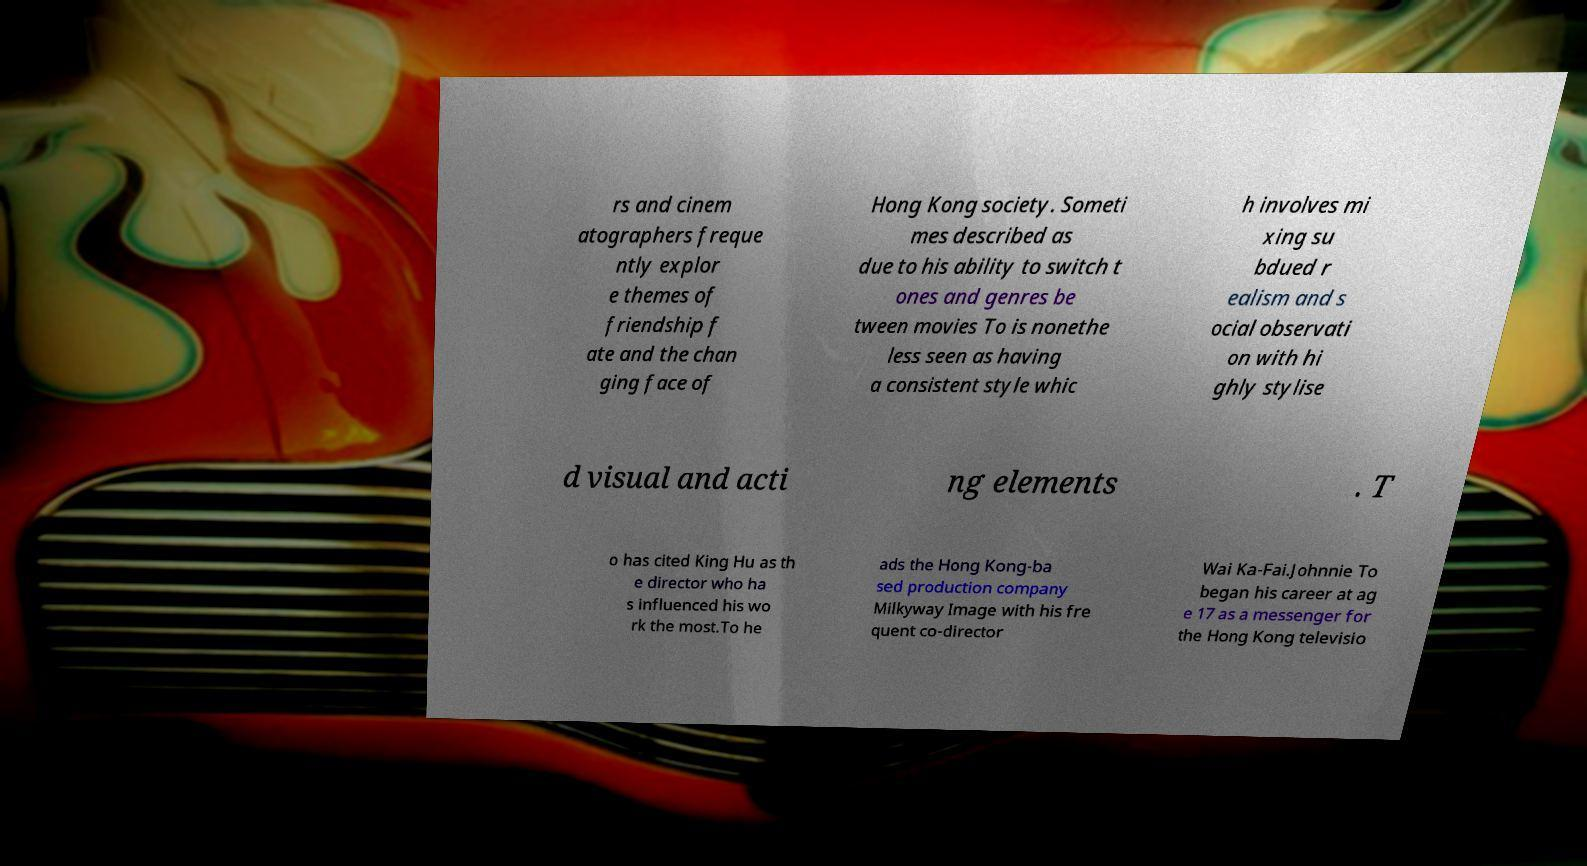For documentation purposes, I need the text within this image transcribed. Could you provide that? rs and cinem atographers freque ntly explor e themes of friendship f ate and the chan ging face of Hong Kong society. Someti mes described as due to his ability to switch t ones and genres be tween movies To is nonethe less seen as having a consistent style whic h involves mi xing su bdued r ealism and s ocial observati on with hi ghly stylise d visual and acti ng elements . T o has cited King Hu as th e director who ha s influenced his wo rk the most.To he ads the Hong Kong-ba sed production company Milkyway Image with his fre quent co-director Wai Ka-Fai.Johnnie To began his career at ag e 17 as a messenger for the Hong Kong televisio 